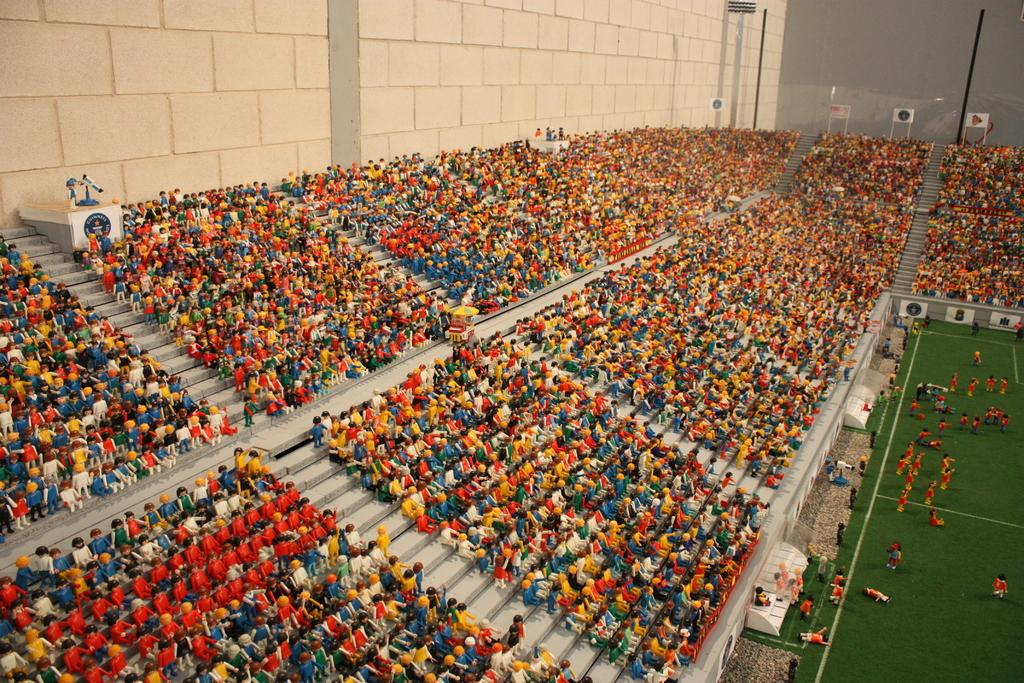What can be seen on the surface in the image? There is a group of toys placed on a surface in the image. What is located on the right side of the image? There are sheds and banners on the right side of the image. What is visible at the top of the image? There is a wall visible at the top of the image. What type of hose is being used to water the neck of the amusement park ride in the image? There is no hose or amusement park ride present in the image. 